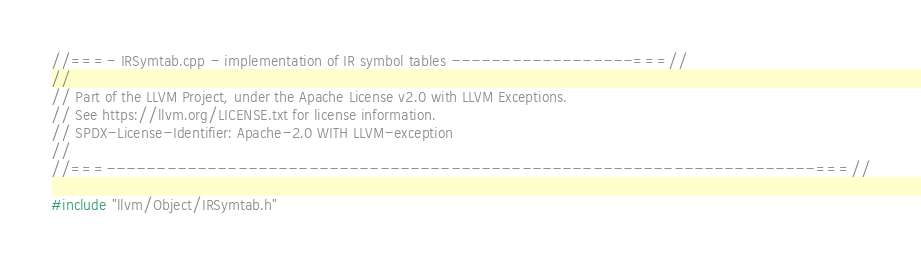Convert code to text. <code><loc_0><loc_0><loc_500><loc_500><_C++_>//===- IRSymtab.cpp - implementation of IR symbol tables ------------------===//
//
// Part of the LLVM Project, under the Apache License v2.0 with LLVM Exceptions.
// See https://llvm.org/LICENSE.txt for license information.
// SPDX-License-Identifier: Apache-2.0 WITH LLVM-exception
//
//===----------------------------------------------------------------------===//

#include "llvm/Object/IRSymtab.h"</code> 